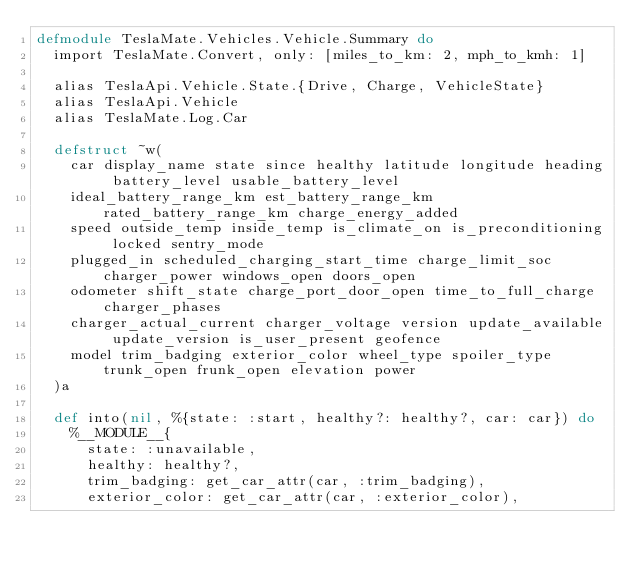Convert code to text. <code><loc_0><loc_0><loc_500><loc_500><_Elixir_>defmodule TeslaMate.Vehicles.Vehicle.Summary do
  import TeslaMate.Convert, only: [miles_to_km: 2, mph_to_kmh: 1]

  alias TeslaApi.Vehicle.State.{Drive, Charge, VehicleState}
  alias TeslaApi.Vehicle
  alias TeslaMate.Log.Car

  defstruct ~w(
    car display_name state since healthy latitude longitude heading battery_level usable_battery_level
    ideal_battery_range_km est_battery_range_km rated_battery_range_km charge_energy_added
    speed outside_temp inside_temp is_climate_on is_preconditioning locked sentry_mode
    plugged_in scheduled_charging_start_time charge_limit_soc charger_power windows_open doors_open
    odometer shift_state charge_port_door_open time_to_full_charge charger_phases
    charger_actual_current charger_voltage version update_available update_version is_user_present geofence
    model trim_badging exterior_color wheel_type spoiler_type trunk_open frunk_open elevation power
  )a

  def into(nil, %{state: :start, healthy?: healthy?, car: car}) do
    %__MODULE__{
      state: :unavailable,
      healthy: healthy?,
      trim_badging: get_car_attr(car, :trim_badging),
      exterior_color: get_car_attr(car, :exterior_color),</code> 